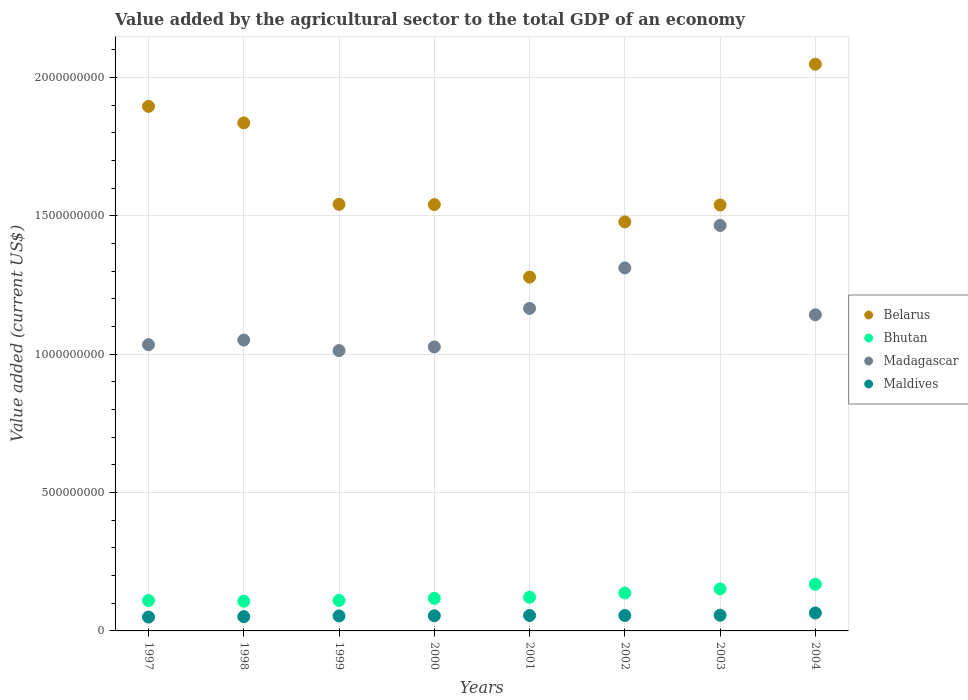Is the number of dotlines equal to the number of legend labels?
Ensure brevity in your answer.  Yes. What is the value added by the agricultural sector to the total GDP in Belarus in 2000?
Provide a succinct answer. 1.54e+09. Across all years, what is the maximum value added by the agricultural sector to the total GDP in Maldives?
Make the answer very short. 6.49e+07. Across all years, what is the minimum value added by the agricultural sector to the total GDP in Belarus?
Give a very brief answer. 1.28e+09. In which year was the value added by the agricultural sector to the total GDP in Belarus minimum?
Make the answer very short. 2001. What is the total value added by the agricultural sector to the total GDP in Maldives in the graph?
Offer a terse response. 4.44e+08. What is the difference between the value added by the agricultural sector to the total GDP in Belarus in 1998 and that in 2000?
Provide a short and direct response. 2.95e+08. What is the difference between the value added by the agricultural sector to the total GDP in Belarus in 1997 and the value added by the agricultural sector to the total GDP in Maldives in 2000?
Give a very brief answer. 1.84e+09. What is the average value added by the agricultural sector to the total GDP in Maldives per year?
Keep it short and to the point. 5.55e+07. In the year 1999, what is the difference between the value added by the agricultural sector to the total GDP in Madagascar and value added by the agricultural sector to the total GDP in Bhutan?
Ensure brevity in your answer.  9.03e+08. What is the ratio of the value added by the agricultural sector to the total GDP in Belarus in 1998 to that in 2000?
Provide a short and direct response. 1.19. What is the difference between the highest and the second highest value added by the agricultural sector to the total GDP in Madagascar?
Provide a short and direct response. 1.54e+08. What is the difference between the highest and the lowest value added by the agricultural sector to the total GDP in Maldives?
Make the answer very short. 1.49e+07. Is the sum of the value added by the agricultural sector to the total GDP in Bhutan in 1999 and 2000 greater than the maximum value added by the agricultural sector to the total GDP in Belarus across all years?
Your response must be concise. No. Is it the case that in every year, the sum of the value added by the agricultural sector to the total GDP in Maldives and value added by the agricultural sector to the total GDP in Belarus  is greater than the sum of value added by the agricultural sector to the total GDP in Madagascar and value added by the agricultural sector to the total GDP in Bhutan?
Your answer should be compact. Yes. Does the value added by the agricultural sector to the total GDP in Belarus monotonically increase over the years?
Offer a terse response. No. Is the value added by the agricultural sector to the total GDP in Madagascar strictly greater than the value added by the agricultural sector to the total GDP in Belarus over the years?
Provide a succinct answer. No. Is the value added by the agricultural sector to the total GDP in Belarus strictly less than the value added by the agricultural sector to the total GDP in Bhutan over the years?
Offer a very short reply. No. How many years are there in the graph?
Keep it short and to the point. 8. Are the values on the major ticks of Y-axis written in scientific E-notation?
Ensure brevity in your answer.  No. Does the graph contain grids?
Provide a succinct answer. Yes. How many legend labels are there?
Make the answer very short. 4. What is the title of the graph?
Ensure brevity in your answer.  Value added by the agricultural sector to the total GDP of an economy. What is the label or title of the X-axis?
Keep it short and to the point. Years. What is the label or title of the Y-axis?
Offer a very short reply. Value added (current US$). What is the Value added (current US$) of Belarus in 1997?
Ensure brevity in your answer.  1.90e+09. What is the Value added (current US$) of Bhutan in 1997?
Keep it short and to the point. 1.10e+08. What is the Value added (current US$) in Madagascar in 1997?
Your answer should be very brief. 1.03e+09. What is the Value added (current US$) of Maldives in 1997?
Offer a very short reply. 5.01e+07. What is the Value added (current US$) of Belarus in 1998?
Your answer should be very brief. 1.84e+09. What is the Value added (current US$) in Bhutan in 1998?
Provide a succinct answer. 1.07e+08. What is the Value added (current US$) of Madagascar in 1998?
Your answer should be very brief. 1.05e+09. What is the Value added (current US$) in Maldives in 1998?
Keep it short and to the point. 5.16e+07. What is the Value added (current US$) in Belarus in 1999?
Keep it short and to the point. 1.54e+09. What is the Value added (current US$) of Bhutan in 1999?
Provide a short and direct response. 1.10e+08. What is the Value added (current US$) in Madagascar in 1999?
Provide a succinct answer. 1.01e+09. What is the Value added (current US$) in Maldives in 1999?
Keep it short and to the point. 5.42e+07. What is the Value added (current US$) of Belarus in 2000?
Keep it short and to the point. 1.54e+09. What is the Value added (current US$) in Bhutan in 2000?
Give a very brief answer. 1.18e+08. What is the Value added (current US$) of Madagascar in 2000?
Provide a short and direct response. 1.03e+09. What is the Value added (current US$) in Maldives in 2000?
Give a very brief answer. 5.47e+07. What is the Value added (current US$) of Belarus in 2001?
Give a very brief answer. 1.28e+09. What is the Value added (current US$) of Bhutan in 2001?
Your answer should be compact. 1.22e+08. What is the Value added (current US$) of Madagascar in 2001?
Ensure brevity in your answer.  1.17e+09. What is the Value added (current US$) in Maldives in 2001?
Offer a very short reply. 5.59e+07. What is the Value added (current US$) of Belarus in 2002?
Your answer should be very brief. 1.48e+09. What is the Value added (current US$) in Bhutan in 2002?
Give a very brief answer. 1.37e+08. What is the Value added (current US$) of Madagascar in 2002?
Provide a succinct answer. 1.31e+09. What is the Value added (current US$) of Maldives in 2002?
Your response must be concise. 5.58e+07. What is the Value added (current US$) in Belarus in 2003?
Your response must be concise. 1.54e+09. What is the Value added (current US$) in Bhutan in 2003?
Ensure brevity in your answer.  1.52e+08. What is the Value added (current US$) in Madagascar in 2003?
Your answer should be compact. 1.47e+09. What is the Value added (current US$) of Maldives in 2003?
Provide a short and direct response. 5.68e+07. What is the Value added (current US$) in Belarus in 2004?
Offer a very short reply. 2.05e+09. What is the Value added (current US$) of Bhutan in 2004?
Provide a succinct answer. 1.68e+08. What is the Value added (current US$) in Madagascar in 2004?
Your response must be concise. 1.14e+09. What is the Value added (current US$) of Maldives in 2004?
Give a very brief answer. 6.49e+07. Across all years, what is the maximum Value added (current US$) in Belarus?
Your answer should be compact. 2.05e+09. Across all years, what is the maximum Value added (current US$) of Bhutan?
Give a very brief answer. 1.68e+08. Across all years, what is the maximum Value added (current US$) in Madagascar?
Your answer should be very brief. 1.47e+09. Across all years, what is the maximum Value added (current US$) of Maldives?
Your answer should be very brief. 6.49e+07. Across all years, what is the minimum Value added (current US$) of Belarus?
Your answer should be very brief. 1.28e+09. Across all years, what is the minimum Value added (current US$) in Bhutan?
Ensure brevity in your answer.  1.07e+08. Across all years, what is the minimum Value added (current US$) in Madagascar?
Give a very brief answer. 1.01e+09. Across all years, what is the minimum Value added (current US$) in Maldives?
Give a very brief answer. 5.01e+07. What is the total Value added (current US$) of Belarus in the graph?
Give a very brief answer. 1.32e+1. What is the total Value added (current US$) in Bhutan in the graph?
Keep it short and to the point. 1.02e+09. What is the total Value added (current US$) of Madagascar in the graph?
Your response must be concise. 9.21e+09. What is the total Value added (current US$) in Maldives in the graph?
Provide a short and direct response. 4.44e+08. What is the difference between the Value added (current US$) in Belarus in 1997 and that in 1998?
Provide a succinct answer. 5.97e+07. What is the difference between the Value added (current US$) in Bhutan in 1997 and that in 1998?
Give a very brief answer. 2.43e+06. What is the difference between the Value added (current US$) of Madagascar in 1997 and that in 1998?
Provide a succinct answer. -1.66e+07. What is the difference between the Value added (current US$) of Maldives in 1997 and that in 1998?
Make the answer very short. -1.50e+06. What is the difference between the Value added (current US$) in Belarus in 1997 and that in 1999?
Provide a short and direct response. 3.54e+08. What is the difference between the Value added (current US$) in Bhutan in 1997 and that in 1999?
Provide a succinct answer. -5.05e+05. What is the difference between the Value added (current US$) in Madagascar in 1997 and that in 1999?
Make the answer very short. 2.13e+07. What is the difference between the Value added (current US$) in Maldives in 1997 and that in 1999?
Offer a very short reply. -4.12e+06. What is the difference between the Value added (current US$) in Belarus in 1997 and that in 2000?
Provide a short and direct response. 3.55e+08. What is the difference between the Value added (current US$) in Bhutan in 1997 and that in 2000?
Offer a terse response. -7.86e+06. What is the difference between the Value added (current US$) of Madagascar in 1997 and that in 2000?
Offer a terse response. 8.17e+06. What is the difference between the Value added (current US$) in Maldives in 1997 and that in 2000?
Your answer should be compact. -4.63e+06. What is the difference between the Value added (current US$) in Belarus in 1997 and that in 2001?
Ensure brevity in your answer.  6.17e+08. What is the difference between the Value added (current US$) of Bhutan in 1997 and that in 2001?
Your answer should be compact. -1.20e+07. What is the difference between the Value added (current US$) of Madagascar in 1997 and that in 2001?
Provide a succinct answer. -1.31e+08. What is the difference between the Value added (current US$) in Maldives in 1997 and that in 2001?
Your answer should be very brief. -5.79e+06. What is the difference between the Value added (current US$) in Belarus in 1997 and that in 2002?
Provide a short and direct response. 4.17e+08. What is the difference between the Value added (current US$) in Bhutan in 1997 and that in 2002?
Your answer should be very brief. -2.72e+07. What is the difference between the Value added (current US$) in Madagascar in 1997 and that in 2002?
Your answer should be very brief. -2.77e+08. What is the difference between the Value added (current US$) of Maldives in 1997 and that in 2002?
Ensure brevity in your answer.  -5.77e+06. What is the difference between the Value added (current US$) of Belarus in 1997 and that in 2003?
Give a very brief answer. 3.56e+08. What is the difference between the Value added (current US$) of Bhutan in 1997 and that in 2003?
Provide a short and direct response. -4.19e+07. What is the difference between the Value added (current US$) of Madagascar in 1997 and that in 2003?
Your answer should be compact. -4.31e+08. What is the difference between the Value added (current US$) in Maldives in 1997 and that in 2003?
Keep it short and to the point. -6.76e+06. What is the difference between the Value added (current US$) in Belarus in 1997 and that in 2004?
Ensure brevity in your answer.  -1.52e+08. What is the difference between the Value added (current US$) of Bhutan in 1997 and that in 2004?
Keep it short and to the point. -5.86e+07. What is the difference between the Value added (current US$) of Madagascar in 1997 and that in 2004?
Your answer should be very brief. -1.08e+08. What is the difference between the Value added (current US$) in Maldives in 1997 and that in 2004?
Offer a terse response. -1.49e+07. What is the difference between the Value added (current US$) of Belarus in 1998 and that in 1999?
Give a very brief answer. 2.94e+08. What is the difference between the Value added (current US$) in Bhutan in 1998 and that in 1999?
Provide a short and direct response. -2.93e+06. What is the difference between the Value added (current US$) in Madagascar in 1998 and that in 1999?
Offer a terse response. 3.80e+07. What is the difference between the Value added (current US$) of Maldives in 1998 and that in 1999?
Make the answer very short. -2.61e+06. What is the difference between the Value added (current US$) in Belarus in 1998 and that in 2000?
Ensure brevity in your answer.  2.95e+08. What is the difference between the Value added (current US$) of Bhutan in 1998 and that in 2000?
Keep it short and to the point. -1.03e+07. What is the difference between the Value added (current US$) in Madagascar in 1998 and that in 2000?
Make the answer very short. 2.48e+07. What is the difference between the Value added (current US$) of Maldives in 1998 and that in 2000?
Give a very brief answer. -3.13e+06. What is the difference between the Value added (current US$) of Belarus in 1998 and that in 2001?
Your answer should be very brief. 5.57e+08. What is the difference between the Value added (current US$) in Bhutan in 1998 and that in 2001?
Offer a very short reply. -1.44e+07. What is the difference between the Value added (current US$) of Madagascar in 1998 and that in 2001?
Your response must be concise. -1.14e+08. What is the difference between the Value added (current US$) in Maldives in 1998 and that in 2001?
Offer a terse response. -4.29e+06. What is the difference between the Value added (current US$) in Belarus in 1998 and that in 2002?
Ensure brevity in your answer.  3.58e+08. What is the difference between the Value added (current US$) of Bhutan in 1998 and that in 2002?
Offer a terse response. -2.96e+07. What is the difference between the Value added (current US$) of Madagascar in 1998 and that in 2002?
Offer a very short reply. -2.61e+08. What is the difference between the Value added (current US$) of Maldives in 1998 and that in 2002?
Provide a succinct answer. -4.26e+06. What is the difference between the Value added (current US$) in Belarus in 1998 and that in 2003?
Offer a very short reply. 2.97e+08. What is the difference between the Value added (current US$) of Bhutan in 1998 and that in 2003?
Your response must be concise. -4.43e+07. What is the difference between the Value added (current US$) of Madagascar in 1998 and that in 2003?
Your response must be concise. -4.14e+08. What is the difference between the Value added (current US$) of Maldives in 1998 and that in 2003?
Keep it short and to the point. -5.26e+06. What is the difference between the Value added (current US$) in Belarus in 1998 and that in 2004?
Offer a terse response. -2.12e+08. What is the difference between the Value added (current US$) of Bhutan in 1998 and that in 2004?
Provide a short and direct response. -6.11e+07. What is the difference between the Value added (current US$) of Madagascar in 1998 and that in 2004?
Keep it short and to the point. -9.14e+07. What is the difference between the Value added (current US$) in Maldives in 1998 and that in 2004?
Your answer should be compact. -1.34e+07. What is the difference between the Value added (current US$) of Belarus in 1999 and that in 2000?
Provide a succinct answer. 9.01e+05. What is the difference between the Value added (current US$) of Bhutan in 1999 and that in 2000?
Your response must be concise. -7.35e+06. What is the difference between the Value added (current US$) of Madagascar in 1999 and that in 2000?
Your response must be concise. -1.32e+07. What is the difference between the Value added (current US$) in Maldives in 1999 and that in 2000?
Your response must be concise. -5.16e+05. What is the difference between the Value added (current US$) in Belarus in 1999 and that in 2001?
Your answer should be compact. 2.63e+08. What is the difference between the Value added (current US$) in Bhutan in 1999 and that in 2001?
Provide a succinct answer. -1.15e+07. What is the difference between the Value added (current US$) of Madagascar in 1999 and that in 2001?
Your answer should be compact. -1.52e+08. What is the difference between the Value added (current US$) of Maldives in 1999 and that in 2001?
Your response must be concise. -1.68e+06. What is the difference between the Value added (current US$) of Belarus in 1999 and that in 2002?
Provide a succinct answer. 6.34e+07. What is the difference between the Value added (current US$) in Bhutan in 1999 and that in 2002?
Offer a very short reply. -2.67e+07. What is the difference between the Value added (current US$) of Madagascar in 1999 and that in 2002?
Offer a terse response. -2.99e+08. What is the difference between the Value added (current US$) of Maldives in 1999 and that in 2002?
Make the answer very short. -1.65e+06. What is the difference between the Value added (current US$) of Belarus in 1999 and that in 2003?
Provide a short and direct response. 2.32e+06. What is the difference between the Value added (current US$) in Bhutan in 1999 and that in 2003?
Your answer should be compact. -4.14e+07. What is the difference between the Value added (current US$) of Madagascar in 1999 and that in 2003?
Make the answer very short. -4.52e+08. What is the difference between the Value added (current US$) of Maldives in 1999 and that in 2003?
Your answer should be very brief. -2.65e+06. What is the difference between the Value added (current US$) in Belarus in 1999 and that in 2004?
Ensure brevity in your answer.  -5.06e+08. What is the difference between the Value added (current US$) of Bhutan in 1999 and that in 2004?
Ensure brevity in your answer.  -5.81e+07. What is the difference between the Value added (current US$) of Madagascar in 1999 and that in 2004?
Offer a very short reply. -1.29e+08. What is the difference between the Value added (current US$) of Maldives in 1999 and that in 2004?
Offer a very short reply. -1.07e+07. What is the difference between the Value added (current US$) in Belarus in 2000 and that in 2001?
Your answer should be very brief. 2.62e+08. What is the difference between the Value added (current US$) in Bhutan in 2000 and that in 2001?
Ensure brevity in your answer.  -4.12e+06. What is the difference between the Value added (current US$) of Madagascar in 2000 and that in 2001?
Ensure brevity in your answer.  -1.39e+08. What is the difference between the Value added (current US$) of Maldives in 2000 and that in 2001?
Provide a short and direct response. -1.16e+06. What is the difference between the Value added (current US$) in Belarus in 2000 and that in 2002?
Provide a short and direct response. 6.25e+07. What is the difference between the Value added (current US$) of Bhutan in 2000 and that in 2002?
Your answer should be compact. -1.93e+07. What is the difference between the Value added (current US$) of Madagascar in 2000 and that in 2002?
Give a very brief answer. -2.86e+08. What is the difference between the Value added (current US$) in Maldives in 2000 and that in 2002?
Provide a succinct answer. -1.14e+06. What is the difference between the Value added (current US$) in Belarus in 2000 and that in 2003?
Your answer should be very brief. 1.42e+06. What is the difference between the Value added (current US$) of Bhutan in 2000 and that in 2003?
Provide a short and direct response. -3.40e+07. What is the difference between the Value added (current US$) of Madagascar in 2000 and that in 2003?
Ensure brevity in your answer.  -4.39e+08. What is the difference between the Value added (current US$) of Maldives in 2000 and that in 2003?
Your answer should be compact. -2.13e+06. What is the difference between the Value added (current US$) of Belarus in 2000 and that in 2004?
Provide a short and direct response. -5.07e+08. What is the difference between the Value added (current US$) in Bhutan in 2000 and that in 2004?
Offer a very short reply. -5.08e+07. What is the difference between the Value added (current US$) in Madagascar in 2000 and that in 2004?
Offer a terse response. -1.16e+08. What is the difference between the Value added (current US$) of Maldives in 2000 and that in 2004?
Your response must be concise. -1.02e+07. What is the difference between the Value added (current US$) of Belarus in 2001 and that in 2002?
Offer a terse response. -1.99e+08. What is the difference between the Value added (current US$) of Bhutan in 2001 and that in 2002?
Keep it short and to the point. -1.52e+07. What is the difference between the Value added (current US$) of Madagascar in 2001 and that in 2002?
Your answer should be very brief. -1.46e+08. What is the difference between the Value added (current US$) in Maldives in 2001 and that in 2002?
Offer a terse response. 2.72e+04. What is the difference between the Value added (current US$) in Belarus in 2001 and that in 2003?
Your response must be concise. -2.61e+08. What is the difference between the Value added (current US$) of Bhutan in 2001 and that in 2003?
Your response must be concise. -2.99e+07. What is the difference between the Value added (current US$) of Madagascar in 2001 and that in 2003?
Provide a short and direct response. -3.00e+08. What is the difference between the Value added (current US$) in Maldives in 2001 and that in 2003?
Provide a succinct answer. -9.67e+05. What is the difference between the Value added (current US$) in Belarus in 2001 and that in 2004?
Make the answer very short. -7.69e+08. What is the difference between the Value added (current US$) of Bhutan in 2001 and that in 2004?
Make the answer very short. -4.67e+07. What is the difference between the Value added (current US$) of Madagascar in 2001 and that in 2004?
Your answer should be very brief. 2.30e+07. What is the difference between the Value added (current US$) in Maldives in 2001 and that in 2004?
Offer a very short reply. -9.06e+06. What is the difference between the Value added (current US$) in Belarus in 2002 and that in 2003?
Keep it short and to the point. -6.11e+07. What is the difference between the Value added (current US$) in Bhutan in 2002 and that in 2003?
Your answer should be very brief. -1.47e+07. What is the difference between the Value added (current US$) in Madagascar in 2002 and that in 2003?
Provide a short and direct response. -1.54e+08. What is the difference between the Value added (current US$) of Maldives in 2002 and that in 2003?
Ensure brevity in your answer.  -9.95e+05. What is the difference between the Value added (current US$) of Belarus in 2002 and that in 2004?
Offer a very short reply. -5.70e+08. What is the difference between the Value added (current US$) of Bhutan in 2002 and that in 2004?
Your answer should be very brief. -3.14e+07. What is the difference between the Value added (current US$) in Madagascar in 2002 and that in 2004?
Your answer should be very brief. 1.69e+08. What is the difference between the Value added (current US$) in Maldives in 2002 and that in 2004?
Your response must be concise. -9.09e+06. What is the difference between the Value added (current US$) of Belarus in 2003 and that in 2004?
Your answer should be compact. -5.09e+08. What is the difference between the Value added (current US$) in Bhutan in 2003 and that in 2004?
Give a very brief answer. -1.68e+07. What is the difference between the Value added (current US$) in Madagascar in 2003 and that in 2004?
Your answer should be compact. 3.23e+08. What is the difference between the Value added (current US$) of Maldives in 2003 and that in 2004?
Give a very brief answer. -8.10e+06. What is the difference between the Value added (current US$) of Belarus in 1997 and the Value added (current US$) of Bhutan in 1998?
Provide a short and direct response. 1.79e+09. What is the difference between the Value added (current US$) of Belarus in 1997 and the Value added (current US$) of Madagascar in 1998?
Provide a succinct answer. 8.45e+08. What is the difference between the Value added (current US$) of Belarus in 1997 and the Value added (current US$) of Maldives in 1998?
Give a very brief answer. 1.84e+09. What is the difference between the Value added (current US$) in Bhutan in 1997 and the Value added (current US$) in Madagascar in 1998?
Provide a succinct answer. -9.41e+08. What is the difference between the Value added (current US$) of Bhutan in 1997 and the Value added (current US$) of Maldives in 1998?
Your response must be concise. 5.83e+07. What is the difference between the Value added (current US$) of Madagascar in 1997 and the Value added (current US$) of Maldives in 1998?
Offer a terse response. 9.83e+08. What is the difference between the Value added (current US$) of Belarus in 1997 and the Value added (current US$) of Bhutan in 1999?
Your answer should be very brief. 1.79e+09. What is the difference between the Value added (current US$) of Belarus in 1997 and the Value added (current US$) of Madagascar in 1999?
Offer a very short reply. 8.83e+08. What is the difference between the Value added (current US$) in Belarus in 1997 and the Value added (current US$) in Maldives in 1999?
Your answer should be compact. 1.84e+09. What is the difference between the Value added (current US$) in Bhutan in 1997 and the Value added (current US$) in Madagascar in 1999?
Provide a succinct answer. -9.03e+08. What is the difference between the Value added (current US$) in Bhutan in 1997 and the Value added (current US$) in Maldives in 1999?
Ensure brevity in your answer.  5.57e+07. What is the difference between the Value added (current US$) of Madagascar in 1997 and the Value added (current US$) of Maldives in 1999?
Ensure brevity in your answer.  9.80e+08. What is the difference between the Value added (current US$) in Belarus in 1997 and the Value added (current US$) in Bhutan in 2000?
Provide a short and direct response. 1.78e+09. What is the difference between the Value added (current US$) in Belarus in 1997 and the Value added (current US$) in Madagascar in 2000?
Give a very brief answer. 8.69e+08. What is the difference between the Value added (current US$) of Belarus in 1997 and the Value added (current US$) of Maldives in 2000?
Your answer should be very brief. 1.84e+09. What is the difference between the Value added (current US$) of Bhutan in 1997 and the Value added (current US$) of Madagascar in 2000?
Your answer should be compact. -9.16e+08. What is the difference between the Value added (current US$) in Bhutan in 1997 and the Value added (current US$) in Maldives in 2000?
Ensure brevity in your answer.  5.51e+07. What is the difference between the Value added (current US$) of Madagascar in 1997 and the Value added (current US$) of Maldives in 2000?
Offer a very short reply. 9.80e+08. What is the difference between the Value added (current US$) of Belarus in 1997 and the Value added (current US$) of Bhutan in 2001?
Offer a terse response. 1.77e+09. What is the difference between the Value added (current US$) in Belarus in 1997 and the Value added (current US$) in Madagascar in 2001?
Your response must be concise. 7.30e+08. What is the difference between the Value added (current US$) of Belarus in 1997 and the Value added (current US$) of Maldives in 2001?
Offer a terse response. 1.84e+09. What is the difference between the Value added (current US$) in Bhutan in 1997 and the Value added (current US$) in Madagascar in 2001?
Provide a short and direct response. -1.06e+09. What is the difference between the Value added (current US$) of Bhutan in 1997 and the Value added (current US$) of Maldives in 2001?
Your answer should be very brief. 5.40e+07. What is the difference between the Value added (current US$) of Madagascar in 1997 and the Value added (current US$) of Maldives in 2001?
Ensure brevity in your answer.  9.79e+08. What is the difference between the Value added (current US$) in Belarus in 1997 and the Value added (current US$) in Bhutan in 2002?
Provide a short and direct response. 1.76e+09. What is the difference between the Value added (current US$) of Belarus in 1997 and the Value added (current US$) of Madagascar in 2002?
Your answer should be very brief. 5.84e+08. What is the difference between the Value added (current US$) in Belarus in 1997 and the Value added (current US$) in Maldives in 2002?
Ensure brevity in your answer.  1.84e+09. What is the difference between the Value added (current US$) of Bhutan in 1997 and the Value added (current US$) of Madagascar in 2002?
Keep it short and to the point. -1.20e+09. What is the difference between the Value added (current US$) of Bhutan in 1997 and the Value added (current US$) of Maldives in 2002?
Your answer should be compact. 5.40e+07. What is the difference between the Value added (current US$) in Madagascar in 1997 and the Value added (current US$) in Maldives in 2002?
Provide a succinct answer. 9.79e+08. What is the difference between the Value added (current US$) in Belarus in 1997 and the Value added (current US$) in Bhutan in 2003?
Ensure brevity in your answer.  1.74e+09. What is the difference between the Value added (current US$) of Belarus in 1997 and the Value added (current US$) of Madagascar in 2003?
Provide a succinct answer. 4.30e+08. What is the difference between the Value added (current US$) of Belarus in 1997 and the Value added (current US$) of Maldives in 2003?
Your answer should be compact. 1.84e+09. What is the difference between the Value added (current US$) in Bhutan in 1997 and the Value added (current US$) in Madagascar in 2003?
Your response must be concise. -1.36e+09. What is the difference between the Value added (current US$) of Bhutan in 1997 and the Value added (current US$) of Maldives in 2003?
Keep it short and to the point. 5.30e+07. What is the difference between the Value added (current US$) of Madagascar in 1997 and the Value added (current US$) of Maldives in 2003?
Your answer should be compact. 9.78e+08. What is the difference between the Value added (current US$) in Belarus in 1997 and the Value added (current US$) in Bhutan in 2004?
Ensure brevity in your answer.  1.73e+09. What is the difference between the Value added (current US$) of Belarus in 1997 and the Value added (current US$) of Madagascar in 2004?
Provide a short and direct response. 7.53e+08. What is the difference between the Value added (current US$) of Belarus in 1997 and the Value added (current US$) of Maldives in 2004?
Offer a terse response. 1.83e+09. What is the difference between the Value added (current US$) in Bhutan in 1997 and the Value added (current US$) in Madagascar in 2004?
Keep it short and to the point. -1.03e+09. What is the difference between the Value added (current US$) of Bhutan in 1997 and the Value added (current US$) of Maldives in 2004?
Your response must be concise. 4.49e+07. What is the difference between the Value added (current US$) of Madagascar in 1997 and the Value added (current US$) of Maldives in 2004?
Ensure brevity in your answer.  9.70e+08. What is the difference between the Value added (current US$) of Belarus in 1998 and the Value added (current US$) of Bhutan in 1999?
Provide a succinct answer. 1.73e+09. What is the difference between the Value added (current US$) in Belarus in 1998 and the Value added (current US$) in Madagascar in 1999?
Your answer should be compact. 8.23e+08. What is the difference between the Value added (current US$) of Belarus in 1998 and the Value added (current US$) of Maldives in 1999?
Your response must be concise. 1.78e+09. What is the difference between the Value added (current US$) of Bhutan in 1998 and the Value added (current US$) of Madagascar in 1999?
Ensure brevity in your answer.  -9.06e+08. What is the difference between the Value added (current US$) of Bhutan in 1998 and the Value added (current US$) of Maldives in 1999?
Provide a short and direct response. 5.32e+07. What is the difference between the Value added (current US$) of Madagascar in 1998 and the Value added (current US$) of Maldives in 1999?
Keep it short and to the point. 9.97e+08. What is the difference between the Value added (current US$) of Belarus in 1998 and the Value added (current US$) of Bhutan in 2000?
Offer a very short reply. 1.72e+09. What is the difference between the Value added (current US$) in Belarus in 1998 and the Value added (current US$) in Madagascar in 2000?
Keep it short and to the point. 8.10e+08. What is the difference between the Value added (current US$) of Belarus in 1998 and the Value added (current US$) of Maldives in 2000?
Provide a short and direct response. 1.78e+09. What is the difference between the Value added (current US$) of Bhutan in 1998 and the Value added (current US$) of Madagascar in 2000?
Provide a short and direct response. -9.19e+08. What is the difference between the Value added (current US$) in Bhutan in 1998 and the Value added (current US$) in Maldives in 2000?
Ensure brevity in your answer.  5.27e+07. What is the difference between the Value added (current US$) of Madagascar in 1998 and the Value added (current US$) of Maldives in 2000?
Provide a short and direct response. 9.96e+08. What is the difference between the Value added (current US$) of Belarus in 1998 and the Value added (current US$) of Bhutan in 2001?
Provide a short and direct response. 1.71e+09. What is the difference between the Value added (current US$) in Belarus in 1998 and the Value added (current US$) in Madagascar in 2001?
Offer a very short reply. 6.71e+08. What is the difference between the Value added (current US$) in Belarus in 1998 and the Value added (current US$) in Maldives in 2001?
Provide a short and direct response. 1.78e+09. What is the difference between the Value added (current US$) in Bhutan in 1998 and the Value added (current US$) in Madagascar in 2001?
Offer a very short reply. -1.06e+09. What is the difference between the Value added (current US$) in Bhutan in 1998 and the Value added (current US$) in Maldives in 2001?
Provide a short and direct response. 5.16e+07. What is the difference between the Value added (current US$) of Madagascar in 1998 and the Value added (current US$) of Maldives in 2001?
Provide a short and direct response. 9.95e+08. What is the difference between the Value added (current US$) of Belarus in 1998 and the Value added (current US$) of Bhutan in 2002?
Your answer should be very brief. 1.70e+09. What is the difference between the Value added (current US$) of Belarus in 1998 and the Value added (current US$) of Madagascar in 2002?
Ensure brevity in your answer.  5.24e+08. What is the difference between the Value added (current US$) in Belarus in 1998 and the Value added (current US$) in Maldives in 2002?
Offer a terse response. 1.78e+09. What is the difference between the Value added (current US$) in Bhutan in 1998 and the Value added (current US$) in Madagascar in 2002?
Ensure brevity in your answer.  -1.20e+09. What is the difference between the Value added (current US$) in Bhutan in 1998 and the Value added (current US$) in Maldives in 2002?
Provide a short and direct response. 5.16e+07. What is the difference between the Value added (current US$) in Madagascar in 1998 and the Value added (current US$) in Maldives in 2002?
Keep it short and to the point. 9.95e+08. What is the difference between the Value added (current US$) in Belarus in 1998 and the Value added (current US$) in Bhutan in 2003?
Ensure brevity in your answer.  1.68e+09. What is the difference between the Value added (current US$) of Belarus in 1998 and the Value added (current US$) of Madagascar in 2003?
Your response must be concise. 3.71e+08. What is the difference between the Value added (current US$) in Belarus in 1998 and the Value added (current US$) in Maldives in 2003?
Offer a terse response. 1.78e+09. What is the difference between the Value added (current US$) in Bhutan in 1998 and the Value added (current US$) in Madagascar in 2003?
Provide a succinct answer. -1.36e+09. What is the difference between the Value added (current US$) of Bhutan in 1998 and the Value added (current US$) of Maldives in 2003?
Give a very brief answer. 5.06e+07. What is the difference between the Value added (current US$) in Madagascar in 1998 and the Value added (current US$) in Maldives in 2003?
Offer a very short reply. 9.94e+08. What is the difference between the Value added (current US$) of Belarus in 1998 and the Value added (current US$) of Bhutan in 2004?
Provide a succinct answer. 1.67e+09. What is the difference between the Value added (current US$) in Belarus in 1998 and the Value added (current US$) in Madagascar in 2004?
Give a very brief answer. 6.94e+08. What is the difference between the Value added (current US$) in Belarus in 1998 and the Value added (current US$) in Maldives in 2004?
Make the answer very short. 1.77e+09. What is the difference between the Value added (current US$) of Bhutan in 1998 and the Value added (current US$) of Madagascar in 2004?
Provide a short and direct response. -1.04e+09. What is the difference between the Value added (current US$) in Bhutan in 1998 and the Value added (current US$) in Maldives in 2004?
Your answer should be very brief. 4.25e+07. What is the difference between the Value added (current US$) in Madagascar in 1998 and the Value added (current US$) in Maldives in 2004?
Your answer should be compact. 9.86e+08. What is the difference between the Value added (current US$) in Belarus in 1999 and the Value added (current US$) in Bhutan in 2000?
Give a very brief answer. 1.42e+09. What is the difference between the Value added (current US$) in Belarus in 1999 and the Value added (current US$) in Madagascar in 2000?
Give a very brief answer. 5.15e+08. What is the difference between the Value added (current US$) in Belarus in 1999 and the Value added (current US$) in Maldives in 2000?
Offer a terse response. 1.49e+09. What is the difference between the Value added (current US$) in Bhutan in 1999 and the Value added (current US$) in Madagascar in 2000?
Offer a terse response. -9.16e+08. What is the difference between the Value added (current US$) in Bhutan in 1999 and the Value added (current US$) in Maldives in 2000?
Provide a succinct answer. 5.56e+07. What is the difference between the Value added (current US$) of Madagascar in 1999 and the Value added (current US$) of Maldives in 2000?
Keep it short and to the point. 9.58e+08. What is the difference between the Value added (current US$) of Belarus in 1999 and the Value added (current US$) of Bhutan in 2001?
Make the answer very short. 1.42e+09. What is the difference between the Value added (current US$) of Belarus in 1999 and the Value added (current US$) of Madagascar in 2001?
Offer a very short reply. 3.76e+08. What is the difference between the Value added (current US$) of Belarus in 1999 and the Value added (current US$) of Maldives in 2001?
Your answer should be compact. 1.49e+09. What is the difference between the Value added (current US$) in Bhutan in 1999 and the Value added (current US$) in Madagascar in 2001?
Your response must be concise. -1.06e+09. What is the difference between the Value added (current US$) of Bhutan in 1999 and the Value added (current US$) of Maldives in 2001?
Offer a terse response. 5.45e+07. What is the difference between the Value added (current US$) in Madagascar in 1999 and the Value added (current US$) in Maldives in 2001?
Give a very brief answer. 9.57e+08. What is the difference between the Value added (current US$) of Belarus in 1999 and the Value added (current US$) of Bhutan in 2002?
Offer a terse response. 1.40e+09. What is the difference between the Value added (current US$) in Belarus in 1999 and the Value added (current US$) in Madagascar in 2002?
Your answer should be very brief. 2.30e+08. What is the difference between the Value added (current US$) of Belarus in 1999 and the Value added (current US$) of Maldives in 2002?
Give a very brief answer. 1.49e+09. What is the difference between the Value added (current US$) of Bhutan in 1999 and the Value added (current US$) of Madagascar in 2002?
Provide a short and direct response. -1.20e+09. What is the difference between the Value added (current US$) in Bhutan in 1999 and the Value added (current US$) in Maldives in 2002?
Give a very brief answer. 5.45e+07. What is the difference between the Value added (current US$) in Madagascar in 1999 and the Value added (current US$) in Maldives in 2002?
Ensure brevity in your answer.  9.57e+08. What is the difference between the Value added (current US$) in Belarus in 1999 and the Value added (current US$) in Bhutan in 2003?
Provide a short and direct response. 1.39e+09. What is the difference between the Value added (current US$) of Belarus in 1999 and the Value added (current US$) of Madagascar in 2003?
Make the answer very short. 7.62e+07. What is the difference between the Value added (current US$) of Belarus in 1999 and the Value added (current US$) of Maldives in 2003?
Make the answer very short. 1.48e+09. What is the difference between the Value added (current US$) of Bhutan in 1999 and the Value added (current US$) of Madagascar in 2003?
Your response must be concise. -1.36e+09. What is the difference between the Value added (current US$) in Bhutan in 1999 and the Value added (current US$) in Maldives in 2003?
Provide a succinct answer. 5.35e+07. What is the difference between the Value added (current US$) in Madagascar in 1999 and the Value added (current US$) in Maldives in 2003?
Your answer should be compact. 9.56e+08. What is the difference between the Value added (current US$) in Belarus in 1999 and the Value added (current US$) in Bhutan in 2004?
Your response must be concise. 1.37e+09. What is the difference between the Value added (current US$) in Belarus in 1999 and the Value added (current US$) in Madagascar in 2004?
Keep it short and to the point. 3.99e+08. What is the difference between the Value added (current US$) in Belarus in 1999 and the Value added (current US$) in Maldives in 2004?
Your answer should be compact. 1.48e+09. What is the difference between the Value added (current US$) in Bhutan in 1999 and the Value added (current US$) in Madagascar in 2004?
Make the answer very short. -1.03e+09. What is the difference between the Value added (current US$) of Bhutan in 1999 and the Value added (current US$) of Maldives in 2004?
Provide a short and direct response. 4.54e+07. What is the difference between the Value added (current US$) in Madagascar in 1999 and the Value added (current US$) in Maldives in 2004?
Give a very brief answer. 9.48e+08. What is the difference between the Value added (current US$) of Belarus in 2000 and the Value added (current US$) of Bhutan in 2001?
Offer a very short reply. 1.42e+09. What is the difference between the Value added (current US$) in Belarus in 2000 and the Value added (current US$) in Madagascar in 2001?
Keep it short and to the point. 3.75e+08. What is the difference between the Value added (current US$) of Belarus in 2000 and the Value added (current US$) of Maldives in 2001?
Provide a succinct answer. 1.48e+09. What is the difference between the Value added (current US$) of Bhutan in 2000 and the Value added (current US$) of Madagascar in 2001?
Keep it short and to the point. -1.05e+09. What is the difference between the Value added (current US$) of Bhutan in 2000 and the Value added (current US$) of Maldives in 2001?
Make the answer very short. 6.18e+07. What is the difference between the Value added (current US$) of Madagascar in 2000 and the Value added (current US$) of Maldives in 2001?
Your response must be concise. 9.70e+08. What is the difference between the Value added (current US$) in Belarus in 2000 and the Value added (current US$) in Bhutan in 2002?
Provide a succinct answer. 1.40e+09. What is the difference between the Value added (current US$) of Belarus in 2000 and the Value added (current US$) of Madagascar in 2002?
Provide a succinct answer. 2.29e+08. What is the difference between the Value added (current US$) in Belarus in 2000 and the Value added (current US$) in Maldives in 2002?
Your answer should be very brief. 1.48e+09. What is the difference between the Value added (current US$) in Bhutan in 2000 and the Value added (current US$) in Madagascar in 2002?
Your answer should be compact. -1.19e+09. What is the difference between the Value added (current US$) of Bhutan in 2000 and the Value added (current US$) of Maldives in 2002?
Give a very brief answer. 6.19e+07. What is the difference between the Value added (current US$) of Madagascar in 2000 and the Value added (current US$) of Maldives in 2002?
Make the answer very short. 9.70e+08. What is the difference between the Value added (current US$) in Belarus in 2000 and the Value added (current US$) in Bhutan in 2003?
Provide a short and direct response. 1.39e+09. What is the difference between the Value added (current US$) of Belarus in 2000 and the Value added (current US$) of Madagascar in 2003?
Your answer should be compact. 7.53e+07. What is the difference between the Value added (current US$) in Belarus in 2000 and the Value added (current US$) in Maldives in 2003?
Provide a succinct answer. 1.48e+09. What is the difference between the Value added (current US$) in Bhutan in 2000 and the Value added (current US$) in Madagascar in 2003?
Keep it short and to the point. -1.35e+09. What is the difference between the Value added (current US$) of Bhutan in 2000 and the Value added (current US$) of Maldives in 2003?
Keep it short and to the point. 6.09e+07. What is the difference between the Value added (current US$) in Madagascar in 2000 and the Value added (current US$) in Maldives in 2003?
Give a very brief answer. 9.69e+08. What is the difference between the Value added (current US$) in Belarus in 2000 and the Value added (current US$) in Bhutan in 2004?
Your answer should be very brief. 1.37e+09. What is the difference between the Value added (current US$) in Belarus in 2000 and the Value added (current US$) in Madagascar in 2004?
Provide a short and direct response. 3.98e+08. What is the difference between the Value added (current US$) in Belarus in 2000 and the Value added (current US$) in Maldives in 2004?
Your response must be concise. 1.48e+09. What is the difference between the Value added (current US$) in Bhutan in 2000 and the Value added (current US$) in Madagascar in 2004?
Give a very brief answer. -1.02e+09. What is the difference between the Value added (current US$) in Bhutan in 2000 and the Value added (current US$) in Maldives in 2004?
Keep it short and to the point. 5.28e+07. What is the difference between the Value added (current US$) of Madagascar in 2000 and the Value added (current US$) of Maldives in 2004?
Offer a terse response. 9.61e+08. What is the difference between the Value added (current US$) in Belarus in 2001 and the Value added (current US$) in Bhutan in 2002?
Your answer should be compact. 1.14e+09. What is the difference between the Value added (current US$) of Belarus in 2001 and the Value added (current US$) of Madagascar in 2002?
Your answer should be compact. -3.31e+07. What is the difference between the Value added (current US$) of Belarus in 2001 and the Value added (current US$) of Maldives in 2002?
Keep it short and to the point. 1.22e+09. What is the difference between the Value added (current US$) of Bhutan in 2001 and the Value added (current US$) of Madagascar in 2002?
Provide a succinct answer. -1.19e+09. What is the difference between the Value added (current US$) in Bhutan in 2001 and the Value added (current US$) in Maldives in 2002?
Offer a very short reply. 6.60e+07. What is the difference between the Value added (current US$) in Madagascar in 2001 and the Value added (current US$) in Maldives in 2002?
Your answer should be compact. 1.11e+09. What is the difference between the Value added (current US$) in Belarus in 2001 and the Value added (current US$) in Bhutan in 2003?
Your answer should be very brief. 1.13e+09. What is the difference between the Value added (current US$) in Belarus in 2001 and the Value added (current US$) in Madagascar in 2003?
Offer a terse response. -1.87e+08. What is the difference between the Value added (current US$) of Belarus in 2001 and the Value added (current US$) of Maldives in 2003?
Ensure brevity in your answer.  1.22e+09. What is the difference between the Value added (current US$) in Bhutan in 2001 and the Value added (current US$) in Madagascar in 2003?
Provide a succinct answer. -1.34e+09. What is the difference between the Value added (current US$) of Bhutan in 2001 and the Value added (current US$) of Maldives in 2003?
Offer a very short reply. 6.50e+07. What is the difference between the Value added (current US$) of Madagascar in 2001 and the Value added (current US$) of Maldives in 2003?
Your response must be concise. 1.11e+09. What is the difference between the Value added (current US$) in Belarus in 2001 and the Value added (current US$) in Bhutan in 2004?
Make the answer very short. 1.11e+09. What is the difference between the Value added (current US$) of Belarus in 2001 and the Value added (current US$) of Madagascar in 2004?
Your answer should be compact. 1.36e+08. What is the difference between the Value added (current US$) in Belarus in 2001 and the Value added (current US$) in Maldives in 2004?
Provide a succinct answer. 1.21e+09. What is the difference between the Value added (current US$) in Bhutan in 2001 and the Value added (current US$) in Madagascar in 2004?
Offer a very short reply. -1.02e+09. What is the difference between the Value added (current US$) in Bhutan in 2001 and the Value added (current US$) in Maldives in 2004?
Keep it short and to the point. 5.69e+07. What is the difference between the Value added (current US$) of Madagascar in 2001 and the Value added (current US$) of Maldives in 2004?
Your answer should be compact. 1.10e+09. What is the difference between the Value added (current US$) of Belarus in 2002 and the Value added (current US$) of Bhutan in 2003?
Give a very brief answer. 1.33e+09. What is the difference between the Value added (current US$) in Belarus in 2002 and the Value added (current US$) in Madagascar in 2003?
Provide a succinct answer. 1.28e+07. What is the difference between the Value added (current US$) in Belarus in 2002 and the Value added (current US$) in Maldives in 2003?
Give a very brief answer. 1.42e+09. What is the difference between the Value added (current US$) of Bhutan in 2002 and the Value added (current US$) of Madagascar in 2003?
Give a very brief answer. -1.33e+09. What is the difference between the Value added (current US$) in Bhutan in 2002 and the Value added (current US$) in Maldives in 2003?
Your answer should be compact. 8.02e+07. What is the difference between the Value added (current US$) in Madagascar in 2002 and the Value added (current US$) in Maldives in 2003?
Offer a terse response. 1.26e+09. What is the difference between the Value added (current US$) in Belarus in 2002 and the Value added (current US$) in Bhutan in 2004?
Your response must be concise. 1.31e+09. What is the difference between the Value added (current US$) of Belarus in 2002 and the Value added (current US$) of Madagascar in 2004?
Give a very brief answer. 3.36e+08. What is the difference between the Value added (current US$) in Belarus in 2002 and the Value added (current US$) in Maldives in 2004?
Provide a short and direct response. 1.41e+09. What is the difference between the Value added (current US$) of Bhutan in 2002 and the Value added (current US$) of Madagascar in 2004?
Provide a short and direct response. -1.01e+09. What is the difference between the Value added (current US$) in Bhutan in 2002 and the Value added (current US$) in Maldives in 2004?
Give a very brief answer. 7.21e+07. What is the difference between the Value added (current US$) of Madagascar in 2002 and the Value added (current US$) of Maldives in 2004?
Your answer should be compact. 1.25e+09. What is the difference between the Value added (current US$) of Belarus in 2003 and the Value added (current US$) of Bhutan in 2004?
Offer a very short reply. 1.37e+09. What is the difference between the Value added (current US$) in Belarus in 2003 and the Value added (current US$) in Madagascar in 2004?
Make the answer very short. 3.97e+08. What is the difference between the Value added (current US$) in Belarus in 2003 and the Value added (current US$) in Maldives in 2004?
Provide a succinct answer. 1.47e+09. What is the difference between the Value added (current US$) of Bhutan in 2003 and the Value added (current US$) of Madagascar in 2004?
Offer a terse response. -9.91e+08. What is the difference between the Value added (current US$) in Bhutan in 2003 and the Value added (current US$) in Maldives in 2004?
Offer a terse response. 8.68e+07. What is the difference between the Value added (current US$) in Madagascar in 2003 and the Value added (current US$) in Maldives in 2004?
Provide a succinct answer. 1.40e+09. What is the average Value added (current US$) of Belarus per year?
Ensure brevity in your answer.  1.64e+09. What is the average Value added (current US$) in Bhutan per year?
Your response must be concise. 1.28e+08. What is the average Value added (current US$) of Madagascar per year?
Provide a short and direct response. 1.15e+09. What is the average Value added (current US$) in Maldives per year?
Offer a terse response. 5.55e+07. In the year 1997, what is the difference between the Value added (current US$) of Belarus and Value added (current US$) of Bhutan?
Offer a very short reply. 1.79e+09. In the year 1997, what is the difference between the Value added (current US$) of Belarus and Value added (current US$) of Madagascar?
Offer a terse response. 8.61e+08. In the year 1997, what is the difference between the Value added (current US$) in Belarus and Value added (current US$) in Maldives?
Your answer should be compact. 1.85e+09. In the year 1997, what is the difference between the Value added (current US$) in Bhutan and Value added (current US$) in Madagascar?
Provide a short and direct response. -9.25e+08. In the year 1997, what is the difference between the Value added (current US$) of Bhutan and Value added (current US$) of Maldives?
Make the answer very short. 5.98e+07. In the year 1997, what is the difference between the Value added (current US$) in Madagascar and Value added (current US$) in Maldives?
Keep it short and to the point. 9.84e+08. In the year 1998, what is the difference between the Value added (current US$) of Belarus and Value added (current US$) of Bhutan?
Offer a very short reply. 1.73e+09. In the year 1998, what is the difference between the Value added (current US$) in Belarus and Value added (current US$) in Madagascar?
Offer a terse response. 7.85e+08. In the year 1998, what is the difference between the Value added (current US$) of Belarus and Value added (current US$) of Maldives?
Your answer should be very brief. 1.78e+09. In the year 1998, what is the difference between the Value added (current US$) in Bhutan and Value added (current US$) in Madagascar?
Make the answer very short. -9.44e+08. In the year 1998, what is the difference between the Value added (current US$) of Bhutan and Value added (current US$) of Maldives?
Give a very brief answer. 5.58e+07. In the year 1998, what is the difference between the Value added (current US$) of Madagascar and Value added (current US$) of Maldives?
Offer a terse response. 1.00e+09. In the year 1999, what is the difference between the Value added (current US$) in Belarus and Value added (current US$) in Bhutan?
Provide a short and direct response. 1.43e+09. In the year 1999, what is the difference between the Value added (current US$) of Belarus and Value added (current US$) of Madagascar?
Keep it short and to the point. 5.29e+08. In the year 1999, what is the difference between the Value added (current US$) of Belarus and Value added (current US$) of Maldives?
Your answer should be compact. 1.49e+09. In the year 1999, what is the difference between the Value added (current US$) of Bhutan and Value added (current US$) of Madagascar?
Provide a short and direct response. -9.03e+08. In the year 1999, what is the difference between the Value added (current US$) of Bhutan and Value added (current US$) of Maldives?
Make the answer very short. 5.62e+07. In the year 1999, what is the difference between the Value added (current US$) in Madagascar and Value added (current US$) in Maldives?
Your answer should be very brief. 9.59e+08. In the year 2000, what is the difference between the Value added (current US$) of Belarus and Value added (current US$) of Bhutan?
Your answer should be very brief. 1.42e+09. In the year 2000, what is the difference between the Value added (current US$) in Belarus and Value added (current US$) in Madagascar?
Give a very brief answer. 5.14e+08. In the year 2000, what is the difference between the Value added (current US$) of Belarus and Value added (current US$) of Maldives?
Keep it short and to the point. 1.49e+09. In the year 2000, what is the difference between the Value added (current US$) in Bhutan and Value added (current US$) in Madagascar?
Offer a terse response. -9.09e+08. In the year 2000, what is the difference between the Value added (current US$) of Bhutan and Value added (current US$) of Maldives?
Make the answer very short. 6.30e+07. In the year 2000, what is the difference between the Value added (current US$) in Madagascar and Value added (current US$) in Maldives?
Make the answer very short. 9.72e+08. In the year 2001, what is the difference between the Value added (current US$) in Belarus and Value added (current US$) in Bhutan?
Your response must be concise. 1.16e+09. In the year 2001, what is the difference between the Value added (current US$) of Belarus and Value added (current US$) of Madagascar?
Offer a very short reply. 1.13e+08. In the year 2001, what is the difference between the Value added (current US$) of Belarus and Value added (current US$) of Maldives?
Your answer should be compact. 1.22e+09. In the year 2001, what is the difference between the Value added (current US$) of Bhutan and Value added (current US$) of Madagascar?
Keep it short and to the point. -1.04e+09. In the year 2001, what is the difference between the Value added (current US$) in Bhutan and Value added (current US$) in Maldives?
Make the answer very short. 6.60e+07. In the year 2001, what is the difference between the Value added (current US$) of Madagascar and Value added (current US$) of Maldives?
Provide a short and direct response. 1.11e+09. In the year 2002, what is the difference between the Value added (current US$) of Belarus and Value added (current US$) of Bhutan?
Provide a short and direct response. 1.34e+09. In the year 2002, what is the difference between the Value added (current US$) of Belarus and Value added (current US$) of Madagascar?
Your answer should be very brief. 1.66e+08. In the year 2002, what is the difference between the Value added (current US$) in Belarus and Value added (current US$) in Maldives?
Your answer should be compact. 1.42e+09. In the year 2002, what is the difference between the Value added (current US$) in Bhutan and Value added (current US$) in Madagascar?
Your answer should be very brief. -1.17e+09. In the year 2002, what is the difference between the Value added (current US$) of Bhutan and Value added (current US$) of Maldives?
Give a very brief answer. 8.12e+07. In the year 2002, what is the difference between the Value added (current US$) of Madagascar and Value added (current US$) of Maldives?
Ensure brevity in your answer.  1.26e+09. In the year 2003, what is the difference between the Value added (current US$) of Belarus and Value added (current US$) of Bhutan?
Offer a very short reply. 1.39e+09. In the year 2003, what is the difference between the Value added (current US$) of Belarus and Value added (current US$) of Madagascar?
Your answer should be very brief. 7.39e+07. In the year 2003, what is the difference between the Value added (current US$) of Belarus and Value added (current US$) of Maldives?
Provide a short and direct response. 1.48e+09. In the year 2003, what is the difference between the Value added (current US$) in Bhutan and Value added (current US$) in Madagascar?
Your answer should be very brief. -1.31e+09. In the year 2003, what is the difference between the Value added (current US$) of Bhutan and Value added (current US$) of Maldives?
Offer a terse response. 9.49e+07. In the year 2003, what is the difference between the Value added (current US$) of Madagascar and Value added (current US$) of Maldives?
Ensure brevity in your answer.  1.41e+09. In the year 2004, what is the difference between the Value added (current US$) of Belarus and Value added (current US$) of Bhutan?
Give a very brief answer. 1.88e+09. In the year 2004, what is the difference between the Value added (current US$) in Belarus and Value added (current US$) in Madagascar?
Give a very brief answer. 9.06e+08. In the year 2004, what is the difference between the Value added (current US$) of Belarus and Value added (current US$) of Maldives?
Offer a very short reply. 1.98e+09. In the year 2004, what is the difference between the Value added (current US$) of Bhutan and Value added (current US$) of Madagascar?
Provide a short and direct response. -9.74e+08. In the year 2004, what is the difference between the Value added (current US$) of Bhutan and Value added (current US$) of Maldives?
Make the answer very short. 1.04e+08. In the year 2004, what is the difference between the Value added (current US$) of Madagascar and Value added (current US$) of Maldives?
Provide a succinct answer. 1.08e+09. What is the ratio of the Value added (current US$) in Belarus in 1997 to that in 1998?
Provide a short and direct response. 1.03. What is the ratio of the Value added (current US$) of Bhutan in 1997 to that in 1998?
Your answer should be very brief. 1.02. What is the ratio of the Value added (current US$) of Madagascar in 1997 to that in 1998?
Your answer should be compact. 0.98. What is the ratio of the Value added (current US$) in Maldives in 1997 to that in 1998?
Offer a terse response. 0.97. What is the ratio of the Value added (current US$) of Belarus in 1997 to that in 1999?
Provide a succinct answer. 1.23. What is the ratio of the Value added (current US$) of Madagascar in 1997 to that in 1999?
Make the answer very short. 1.02. What is the ratio of the Value added (current US$) in Maldives in 1997 to that in 1999?
Provide a succinct answer. 0.92. What is the ratio of the Value added (current US$) of Belarus in 1997 to that in 2000?
Your response must be concise. 1.23. What is the ratio of the Value added (current US$) of Bhutan in 1997 to that in 2000?
Your answer should be compact. 0.93. What is the ratio of the Value added (current US$) of Madagascar in 1997 to that in 2000?
Offer a terse response. 1.01. What is the ratio of the Value added (current US$) in Maldives in 1997 to that in 2000?
Provide a short and direct response. 0.92. What is the ratio of the Value added (current US$) of Belarus in 1997 to that in 2001?
Provide a short and direct response. 1.48. What is the ratio of the Value added (current US$) of Bhutan in 1997 to that in 2001?
Your response must be concise. 0.9. What is the ratio of the Value added (current US$) of Madagascar in 1997 to that in 2001?
Keep it short and to the point. 0.89. What is the ratio of the Value added (current US$) in Maldives in 1997 to that in 2001?
Provide a succinct answer. 0.9. What is the ratio of the Value added (current US$) of Belarus in 1997 to that in 2002?
Ensure brevity in your answer.  1.28. What is the ratio of the Value added (current US$) in Bhutan in 1997 to that in 2002?
Provide a short and direct response. 0.8. What is the ratio of the Value added (current US$) of Madagascar in 1997 to that in 2002?
Provide a short and direct response. 0.79. What is the ratio of the Value added (current US$) in Maldives in 1997 to that in 2002?
Ensure brevity in your answer.  0.9. What is the ratio of the Value added (current US$) of Belarus in 1997 to that in 2003?
Keep it short and to the point. 1.23. What is the ratio of the Value added (current US$) of Bhutan in 1997 to that in 2003?
Keep it short and to the point. 0.72. What is the ratio of the Value added (current US$) of Madagascar in 1997 to that in 2003?
Make the answer very short. 0.71. What is the ratio of the Value added (current US$) in Maldives in 1997 to that in 2003?
Your answer should be very brief. 0.88. What is the ratio of the Value added (current US$) of Belarus in 1997 to that in 2004?
Offer a very short reply. 0.93. What is the ratio of the Value added (current US$) in Bhutan in 1997 to that in 2004?
Keep it short and to the point. 0.65. What is the ratio of the Value added (current US$) in Madagascar in 1997 to that in 2004?
Your response must be concise. 0.91. What is the ratio of the Value added (current US$) of Maldives in 1997 to that in 2004?
Your answer should be compact. 0.77. What is the ratio of the Value added (current US$) in Belarus in 1998 to that in 1999?
Your answer should be compact. 1.19. What is the ratio of the Value added (current US$) in Bhutan in 1998 to that in 1999?
Your response must be concise. 0.97. What is the ratio of the Value added (current US$) of Madagascar in 1998 to that in 1999?
Give a very brief answer. 1.04. What is the ratio of the Value added (current US$) in Maldives in 1998 to that in 1999?
Make the answer very short. 0.95. What is the ratio of the Value added (current US$) in Belarus in 1998 to that in 2000?
Offer a terse response. 1.19. What is the ratio of the Value added (current US$) of Bhutan in 1998 to that in 2000?
Offer a terse response. 0.91. What is the ratio of the Value added (current US$) in Madagascar in 1998 to that in 2000?
Provide a succinct answer. 1.02. What is the ratio of the Value added (current US$) in Maldives in 1998 to that in 2000?
Provide a succinct answer. 0.94. What is the ratio of the Value added (current US$) in Belarus in 1998 to that in 2001?
Keep it short and to the point. 1.44. What is the ratio of the Value added (current US$) of Bhutan in 1998 to that in 2001?
Offer a terse response. 0.88. What is the ratio of the Value added (current US$) in Madagascar in 1998 to that in 2001?
Offer a terse response. 0.9. What is the ratio of the Value added (current US$) in Maldives in 1998 to that in 2001?
Offer a very short reply. 0.92. What is the ratio of the Value added (current US$) of Belarus in 1998 to that in 2002?
Your response must be concise. 1.24. What is the ratio of the Value added (current US$) in Bhutan in 1998 to that in 2002?
Offer a terse response. 0.78. What is the ratio of the Value added (current US$) in Madagascar in 1998 to that in 2002?
Give a very brief answer. 0.8. What is the ratio of the Value added (current US$) of Maldives in 1998 to that in 2002?
Your response must be concise. 0.92. What is the ratio of the Value added (current US$) of Belarus in 1998 to that in 2003?
Your answer should be compact. 1.19. What is the ratio of the Value added (current US$) in Bhutan in 1998 to that in 2003?
Offer a very short reply. 0.71. What is the ratio of the Value added (current US$) of Madagascar in 1998 to that in 2003?
Your answer should be compact. 0.72. What is the ratio of the Value added (current US$) in Maldives in 1998 to that in 2003?
Your answer should be compact. 0.91. What is the ratio of the Value added (current US$) in Belarus in 1998 to that in 2004?
Give a very brief answer. 0.9. What is the ratio of the Value added (current US$) of Bhutan in 1998 to that in 2004?
Your response must be concise. 0.64. What is the ratio of the Value added (current US$) in Maldives in 1998 to that in 2004?
Your answer should be very brief. 0.79. What is the ratio of the Value added (current US$) of Belarus in 1999 to that in 2000?
Keep it short and to the point. 1. What is the ratio of the Value added (current US$) in Madagascar in 1999 to that in 2000?
Provide a short and direct response. 0.99. What is the ratio of the Value added (current US$) of Maldives in 1999 to that in 2000?
Offer a terse response. 0.99. What is the ratio of the Value added (current US$) in Belarus in 1999 to that in 2001?
Give a very brief answer. 1.21. What is the ratio of the Value added (current US$) of Bhutan in 1999 to that in 2001?
Make the answer very short. 0.91. What is the ratio of the Value added (current US$) in Madagascar in 1999 to that in 2001?
Make the answer very short. 0.87. What is the ratio of the Value added (current US$) in Maldives in 1999 to that in 2001?
Make the answer very short. 0.97. What is the ratio of the Value added (current US$) of Belarus in 1999 to that in 2002?
Offer a very short reply. 1.04. What is the ratio of the Value added (current US$) of Bhutan in 1999 to that in 2002?
Provide a short and direct response. 0.81. What is the ratio of the Value added (current US$) in Madagascar in 1999 to that in 2002?
Make the answer very short. 0.77. What is the ratio of the Value added (current US$) of Maldives in 1999 to that in 2002?
Your answer should be very brief. 0.97. What is the ratio of the Value added (current US$) in Belarus in 1999 to that in 2003?
Your answer should be very brief. 1. What is the ratio of the Value added (current US$) of Bhutan in 1999 to that in 2003?
Give a very brief answer. 0.73. What is the ratio of the Value added (current US$) of Madagascar in 1999 to that in 2003?
Make the answer very short. 0.69. What is the ratio of the Value added (current US$) in Maldives in 1999 to that in 2003?
Your answer should be very brief. 0.95. What is the ratio of the Value added (current US$) in Belarus in 1999 to that in 2004?
Give a very brief answer. 0.75. What is the ratio of the Value added (current US$) in Bhutan in 1999 to that in 2004?
Provide a succinct answer. 0.66. What is the ratio of the Value added (current US$) in Madagascar in 1999 to that in 2004?
Offer a very short reply. 0.89. What is the ratio of the Value added (current US$) in Maldives in 1999 to that in 2004?
Your answer should be very brief. 0.83. What is the ratio of the Value added (current US$) of Belarus in 2000 to that in 2001?
Your answer should be very brief. 1.2. What is the ratio of the Value added (current US$) of Bhutan in 2000 to that in 2001?
Offer a very short reply. 0.97. What is the ratio of the Value added (current US$) of Madagascar in 2000 to that in 2001?
Your response must be concise. 0.88. What is the ratio of the Value added (current US$) of Maldives in 2000 to that in 2001?
Your answer should be compact. 0.98. What is the ratio of the Value added (current US$) in Belarus in 2000 to that in 2002?
Your response must be concise. 1.04. What is the ratio of the Value added (current US$) of Bhutan in 2000 to that in 2002?
Make the answer very short. 0.86. What is the ratio of the Value added (current US$) in Madagascar in 2000 to that in 2002?
Your answer should be compact. 0.78. What is the ratio of the Value added (current US$) in Maldives in 2000 to that in 2002?
Your answer should be very brief. 0.98. What is the ratio of the Value added (current US$) in Belarus in 2000 to that in 2003?
Your answer should be very brief. 1. What is the ratio of the Value added (current US$) in Bhutan in 2000 to that in 2003?
Provide a short and direct response. 0.78. What is the ratio of the Value added (current US$) in Madagascar in 2000 to that in 2003?
Your answer should be very brief. 0.7. What is the ratio of the Value added (current US$) in Maldives in 2000 to that in 2003?
Your response must be concise. 0.96. What is the ratio of the Value added (current US$) of Belarus in 2000 to that in 2004?
Give a very brief answer. 0.75. What is the ratio of the Value added (current US$) of Bhutan in 2000 to that in 2004?
Your response must be concise. 0.7. What is the ratio of the Value added (current US$) in Madagascar in 2000 to that in 2004?
Make the answer very short. 0.9. What is the ratio of the Value added (current US$) in Maldives in 2000 to that in 2004?
Your answer should be very brief. 0.84. What is the ratio of the Value added (current US$) of Belarus in 2001 to that in 2002?
Give a very brief answer. 0.87. What is the ratio of the Value added (current US$) of Bhutan in 2001 to that in 2002?
Offer a terse response. 0.89. What is the ratio of the Value added (current US$) of Madagascar in 2001 to that in 2002?
Give a very brief answer. 0.89. What is the ratio of the Value added (current US$) of Maldives in 2001 to that in 2002?
Make the answer very short. 1. What is the ratio of the Value added (current US$) of Belarus in 2001 to that in 2003?
Ensure brevity in your answer.  0.83. What is the ratio of the Value added (current US$) of Bhutan in 2001 to that in 2003?
Your response must be concise. 0.8. What is the ratio of the Value added (current US$) in Madagascar in 2001 to that in 2003?
Ensure brevity in your answer.  0.8. What is the ratio of the Value added (current US$) of Maldives in 2001 to that in 2003?
Offer a very short reply. 0.98. What is the ratio of the Value added (current US$) in Belarus in 2001 to that in 2004?
Keep it short and to the point. 0.62. What is the ratio of the Value added (current US$) in Bhutan in 2001 to that in 2004?
Your answer should be very brief. 0.72. What is the ratio of the Value added (current US$) in Madagascar in 2001 to that in 2004?
Keep it short and to the point. 1.02. What is the ratio of the Value added (current US$) of Maldives in 2001 to that in 2004?
Provide a short and direct response. 0.86. What is the ratio of the Value added (current US$) in Belarus in 2002 to that in 2003?
Ensure brevity in your answer.  0.96. What is the ratio of the Value added (current US$) in Bhutan in 2002 to that in 2003?
Keep it short and to the point. 0.9. What is the ratio of the Value added (current US$) in Madagascar in 2002 to that in 2003?
Offer a terse response. 0.9. What is the ratio of the Value added (current US$) in Maldives in 2002 to that in 2003?
Offer a very short reply. 0.98. What is the ratio of the Value added (current US$) of Belarus in 2002 to that in 2004?
Your response must be concise. 0.72. What is the ratio of the Value added (current US$) in Bhutan in 2002 to that in 2004?
Offer a very short reply. 0.81. What is the ratio of the Value added (current US$) in Madagascar in 2002 to that in 2004?
Ensure brevity in your answer.  1.15. What is the ratio of the Value added (current US$) of Maldives in 2002 to that in 2004?
Keep it short and to the point. 0.86. What is the ratio of the Value added (current US$) of Belarus in 2003 to that in 2004?
Your answer should be very brief. 0.75. What is the ratio of the Value added (current US$) in Bhutan in 2003 to that in 2004?
Your answer should be very brief. 0.9. What is the ratio of the Value added (current US$) in Madagascar in 2003 to that in 2004?
Your answer should be compact. 1.28. What is the ratio of the Value added (current US$) of Maldives in 2003 to that in 2004?
Your answer should be very brief. 0.88. What is the difference between the highest and the second highest Value added (current US$) in Belarus?
Give a very brief answer. 1.52e+08. What is the difference between the highest and the second highest Value added (current US$) of Bhutan?
Your response must be concise. 1.68e+07. What is the difference between the highest and the second highest Value added (current US$) of Madagascar?
Make the answer very short. 1.54e+08. What is the difference between the highest and the second highest Value added (current US$) of Maldives?
Your response must be concise. 8.10e+06. What is the difference between the highest and the lowest Value added (current US$) of Belarus?
Offer a terse response. 7.69e+08. What is the difference between the highest and the lowest Value added (current US$) in Bhutan?
Your answer should be compact. 6.11e+07. What is the difference between the highest and the lowest Value added (current US$) in Madagascar?
Ensure brevity in your answer.  4.52e+08. What is the difference between the highest and the lowest Value added (current US$) of Maldives?
Offer a very short reply. 1.49e+07. 